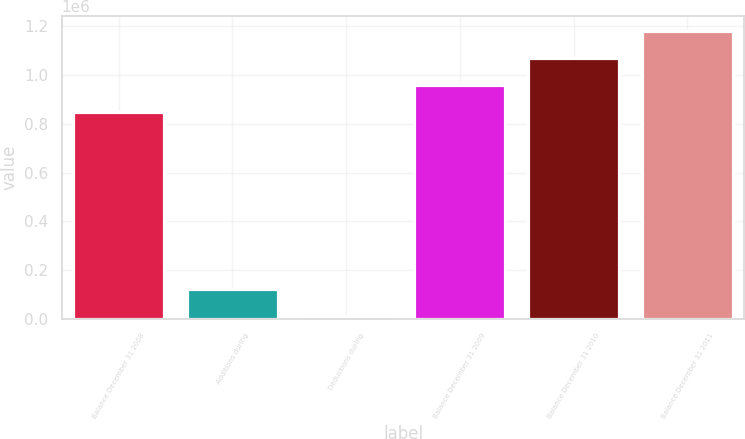Convert chart. <chart><loc_0><loc_0><loc_500><loc_500><bar_chart><fcel>Balance December 31 2008<fcel>Additions during<fcel>Deductions during<fcel>Balance December 31 2009<fcel>Balance December 31 2010<fcel>Balance December 31 2011<nl><fcel>846258<fcel>123441<fcel>11869<fcel>957830<fcel>1.0694e+06<fcel>1.18097e+06<nl></chart> 